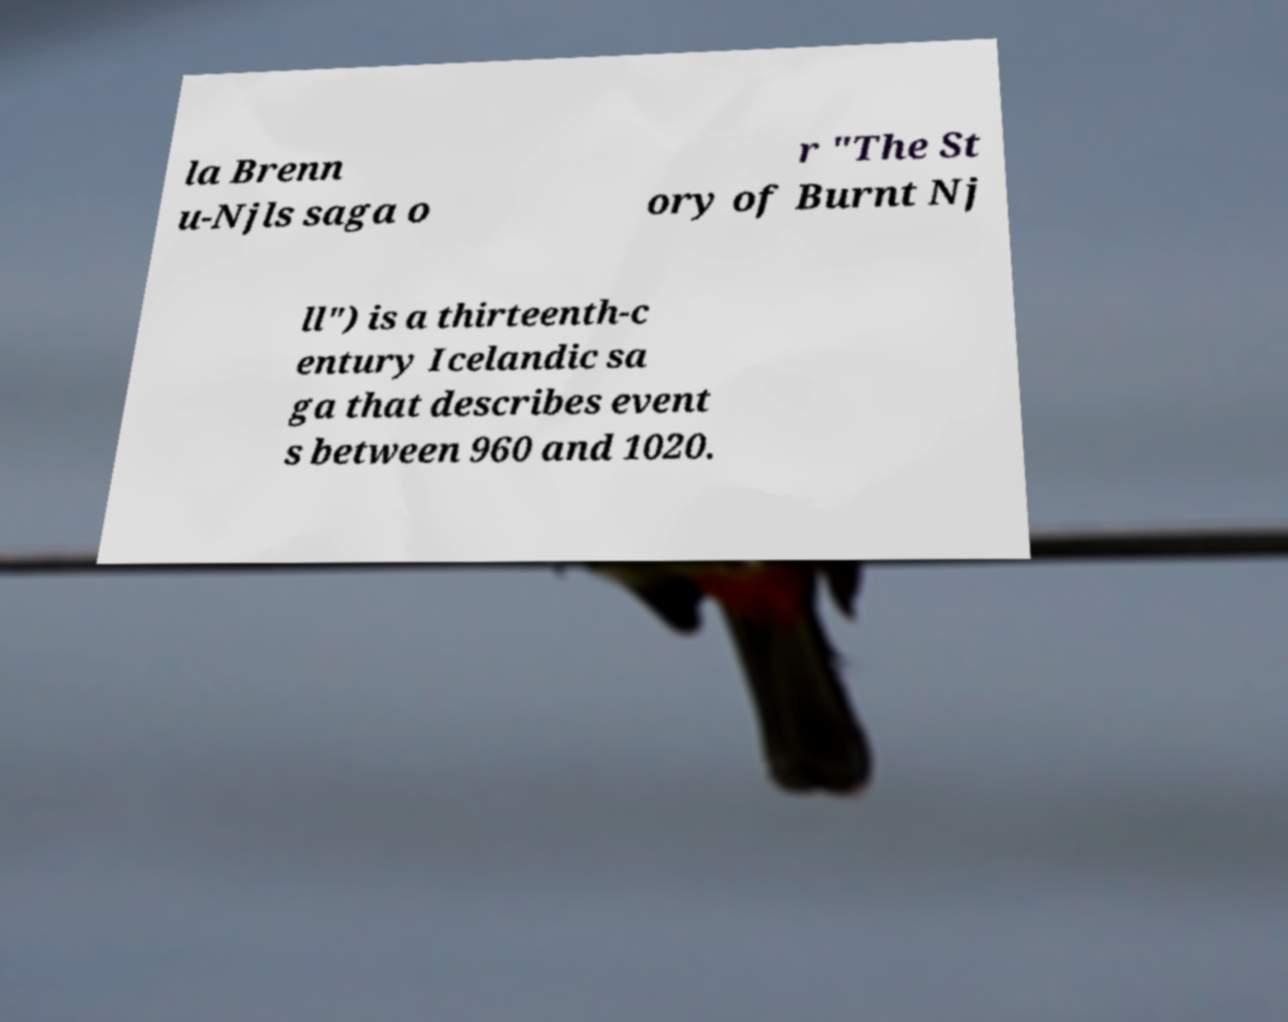Could you assist in decoding the text presented in this image and type it out clearly? la Brenn u-Njls saga o r "The St ory of Burnt Nj ll") is a thirteenth-c entury Icelandic sa ga that describes event s between 960 and 1020. 